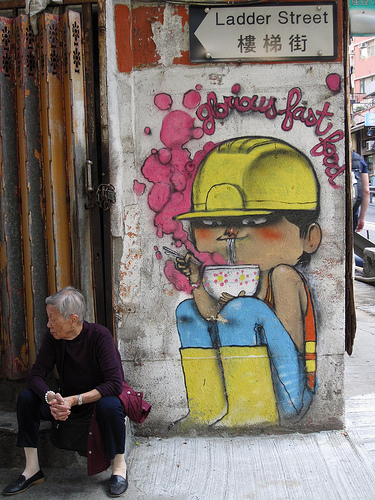<image>
Can you confirm if the hat is on the boot? No. The hat is not positioned on the boot. They may be near each other, but the hat is not supported by or resting on top of the boot. 